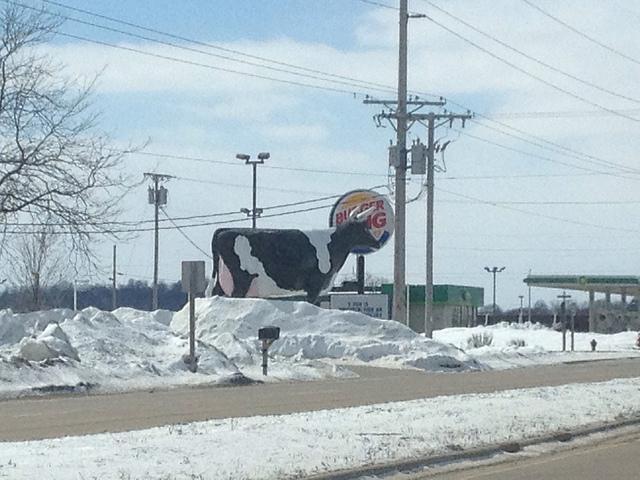How many cows can be seen?
Give a very brief answer. 1. How many skis is the boy holding?
Give a very brief answer. 0. 